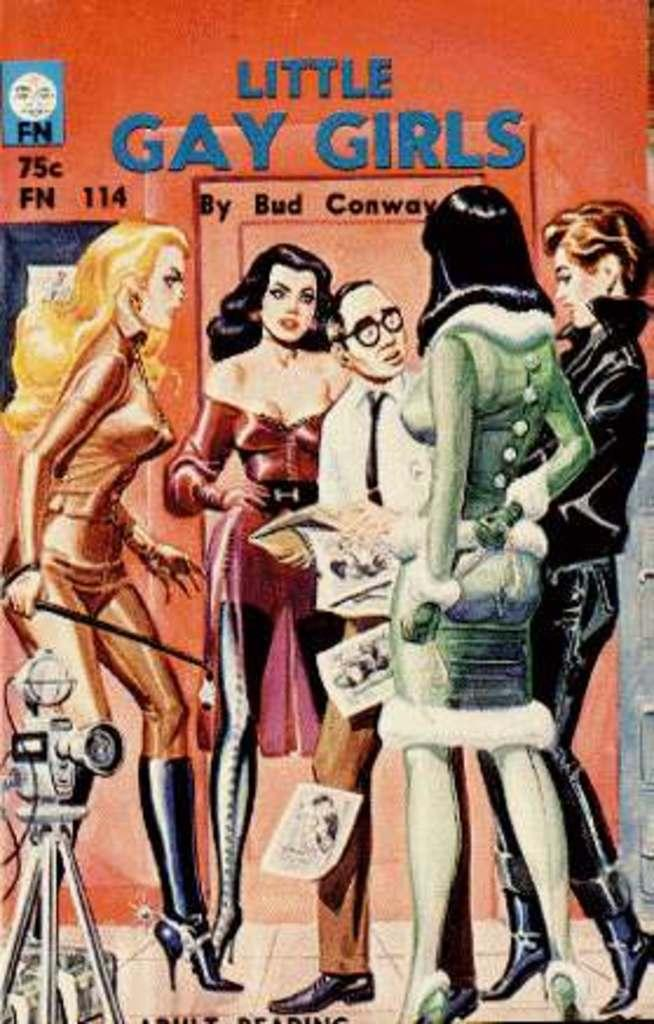What type of visual representation is the image? The image is a poster. What can be seen in the image besides the poster itself? There are persons standing on the floor in the image. What else is featured on the poster besides the image of the persons? The image contains text. What type of cannon is being used by the persons in the image? There is no cannon present in the image; it features a poster with persons standing on the floor and text. What type of cooking equipment can be seen in the image? There is no cooking equipment present in the image. 